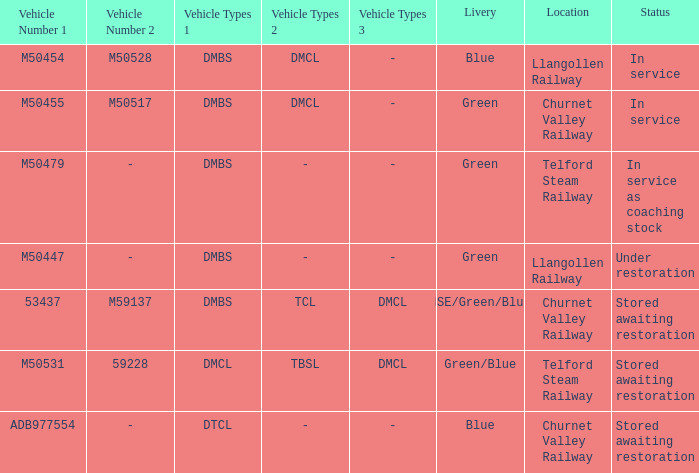What is the current status of the vehicle types dmbs, tcl, and dmcl? Stored awaiting restoration. 